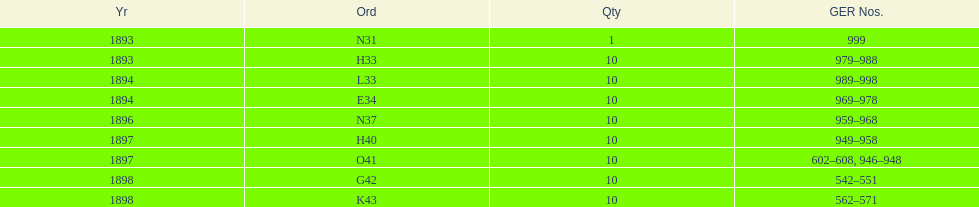What is the last year listed? 1898. Could you parse the entire table as a dict? {'header': ['Yr', 'Ord', 'Qty', 'GER Nos.'], 'rows': [['1893', 'N31', '1', '999'], ['1893', 'H33', '10', '979–988'], ['1894', 'L33', '10', '989–998'], ['1894', 'E34', '10', '969–978'], ['1896', 'N37', '10', '959–968'], ['1897', 'H40', '10', '949–958'], ['1897', 'O41', '10', '602–608, 946–948'], ['1898', 'G42', '10', '542–551'], ['1898', 'K43', '10', '562–571']]} 